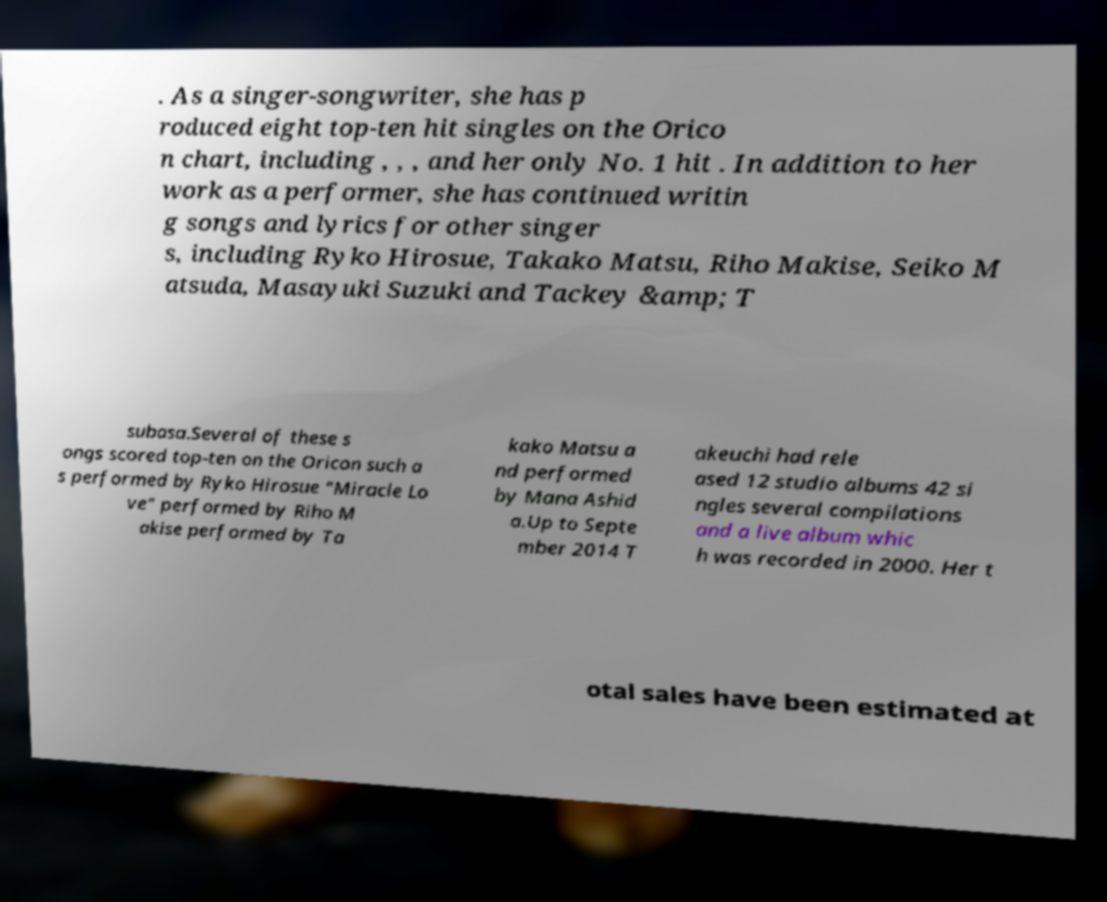Can you accurately transcribe the text from the provided image for me? . As a singer-songwriter, she has p roduced eight top-ten hit singles on the Orico n chart, including , , , and her only No. 1 hit . In addition to her work as a performer, she has continued writin g songs and lyrics for other singer s, including Ryko Hirosue, Takako Matsu, Riho Makise, Seiko M atsuda, Masayuki Suzuki and Tackey &amp; T subasa.Several of these s ongs scored top-ten on the Oricon such a s performed by Ryko Hirosue "Miracle Lo ve" performed by Riho M akise performed by Ta kako Matsu a nd performed by Mana Ashid a.Up to Septe mber 2014 T akeuchi had rele ased 12 studio albums 42 si ngles several compilations and a live album whic h was recorded in 2000. Her t otal sales have been estimated at 